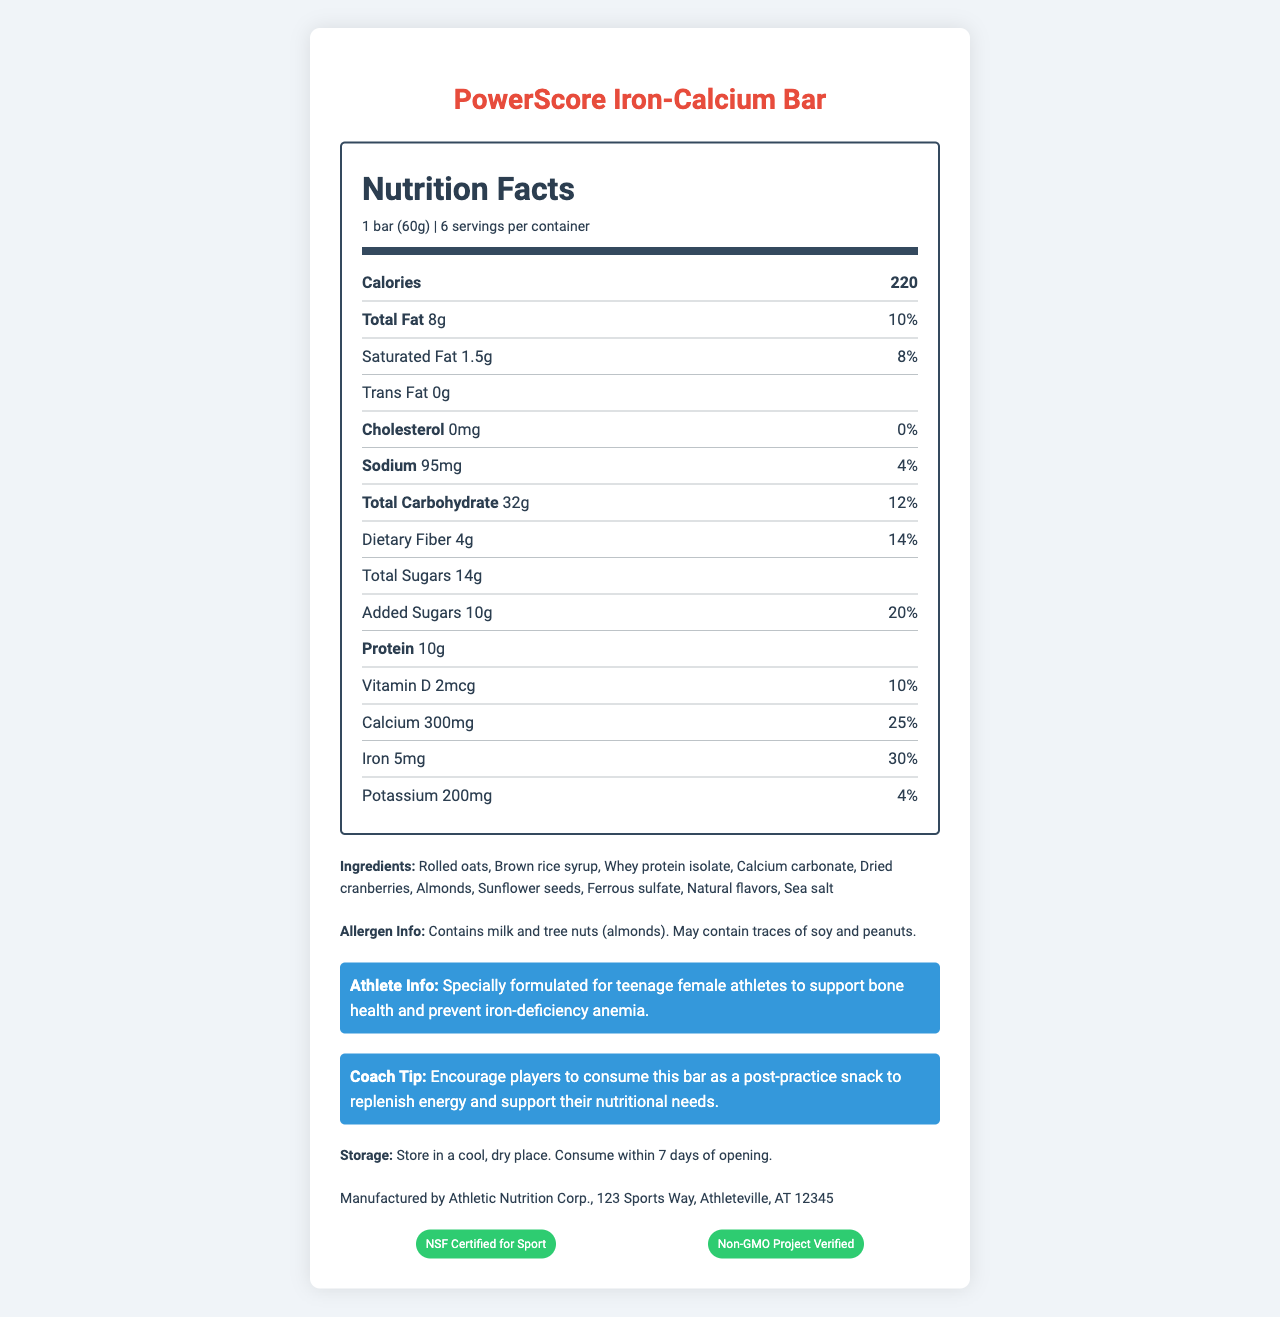what is the serving size of the PowerScore Iron-Calcium Bar? The serving size is clearly mentioned in the nutrition label section of the document.
Answer: 1 bar (60g) how many calories are in one serving of the snack bar? The document lists that each serving contains 220 calories.
Answer: 220 calories what are the two main minerals in this snack bar designed to support? According to the athlete info section, the bar is specially formulated to support bone health (calcium) and prevent iron-deficiency anemia (iron).
Answer: Calcium and Iron how much dietary fiber is in one bar? The amount of dietary fiber per serving is noted as 4g in the nutrition facts.
Answer: 4g who manufactures the PowerScore Iron-Calcium Bar? The manufacturer information section states it is manufactured by Athletic Nutrition Corp.
Answer: Athletic Nutrition Corp. what are some of the main ingredients in this snack bar? The document lists the ingredients clearly under the ingredients section.
Answer: Rolled oats, brown rice syrup, whey protein isolate, calcium carbonate, dried cranberries, almonds, sunflower seeds, ferrous sulfate, natural flavors, sea salt where should this snack bar be stored? The storage instructions indicate that the bar should be stored in a cool, dry place.
Answer: In a cool, dry place what is the allergen information for this snack bar? The allergen information is specifically mentioned under the ingredient section.
Answer: Contains milk and tree nuts (almonds). May contain traces of soy and peanuts. which of the following certifications does the snack bar have? A. USDA Organic B. NSF Certified for Sport C. Fair Trade Certified D. Non-GMO Project Verified The document lists NSF Certified for Sport and Non-GMO Project Verified under the certifications section.
Answer: B and D which nutrient has the highest percent daily value in one serving? A. Calcium B. Iron C. Sodium D. Dietary Fiber Iron has a 30% daily value, which is the highest among the listed nutrients.
Answer: B. Iron does the snack bar contain trans fat? The document specifies that the snack bar contains 0g of trans fat.
Answer: No summarize the main purpose of this document. The document aims to inform about the nutritional content and health benefits of the PowerScore Iron-Calcium Bar, highlighting its formulation to support bone health and prevent anemia in teenage female athletes, along with certifications and storage information.
Answer: To provide detailed nutrition information and specific health benefits of the PowerScore Iron-Calcium Bar, including serving size, ingredients, allergen information, storage instructions, and manufacturer details. what is the price of one PowerScore Iron-Calcium Bar? The document does not provide any information regarding the price of the snack bar.
Answer: Cannot be determined 